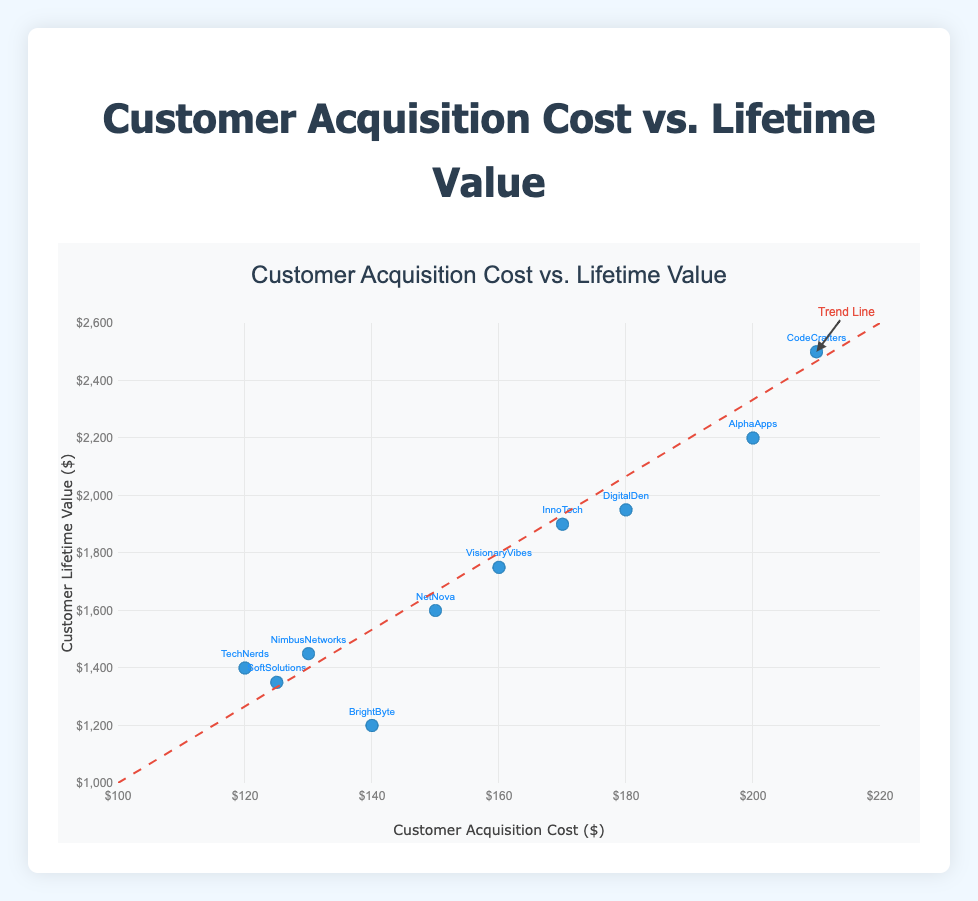What is the title of the plot? The title is displayed prominently at the top of the plot, and it reads "Customer Acquisition Cost vs. Lifetime Value".
Answer: Customer Acquisition Cost vs. Lifetime Value What are the axes titles? The x-axis is labeled "Customer Acquisition Cost ($)" and the y-axis is labeled "Customer Lifetime Value ($)".
Answer: Customer Acquisition Cost ($), Customer Lifetime Value ($) How many companies are represented in the scatter plot? Each marker on the plot represents a different company. Counting the markers, there are 10 companies shown.
Answer: 10 Which company has the highest Customer Lifetime Value (CLV)? By looking at the y-axis values, the highest point corresponds to CodeCrafters with a CLV of $2500.
Answer: CodeCrafters How does the trend line indicate the relationship between Customer Acquisition Cost (CAC) and Customer Lifetime Value (CLV)? The trend line has a positive slope, indicating that as Customer Acquisition Cost increases, Customer Lifetime Value also tends to increase.
Answer: Positive relationship Which company has a Customer Acquisition Cost (CAC) of 160, and what is its Customer Lifetime Value (CLV)? The scatter plot shows VisionaryVibes at the point with a CAC of 160 and a CLV of 1750.
Answer: VisionaryVibes, $1750 What is the average Customer Acquisition Cost (CAC) of all companies? Sum all CAC values: 120 + 200 + 150 + 125 + 180 + 210 + 170 + 140 + 160 + 130 = 1585. There are 10 companies, so the average CAC is 1585/10 = 158.5.
Answer: $158.5 Compare the Customer Lifetime Values of DigitalDen and InnoTech. Which is higher? DigitalDen has a CLV of 1950, and InnoTech has a CLV of 1900. Therefore, DigitalDen's CLV is higher.
Answer: DigitalDen Which company is closest to the trend line? By visually inspecting the proximity of points to the trend line, NetNova appears closest to the trend line.
Answer: NetNova Is there any company whose Customer Acquisition Cost (CAC) is equal to its Customer Lifetime Value (CLV)? By examining the plot, no single data point shows the same values for CAC and CLV.
Answer: No 